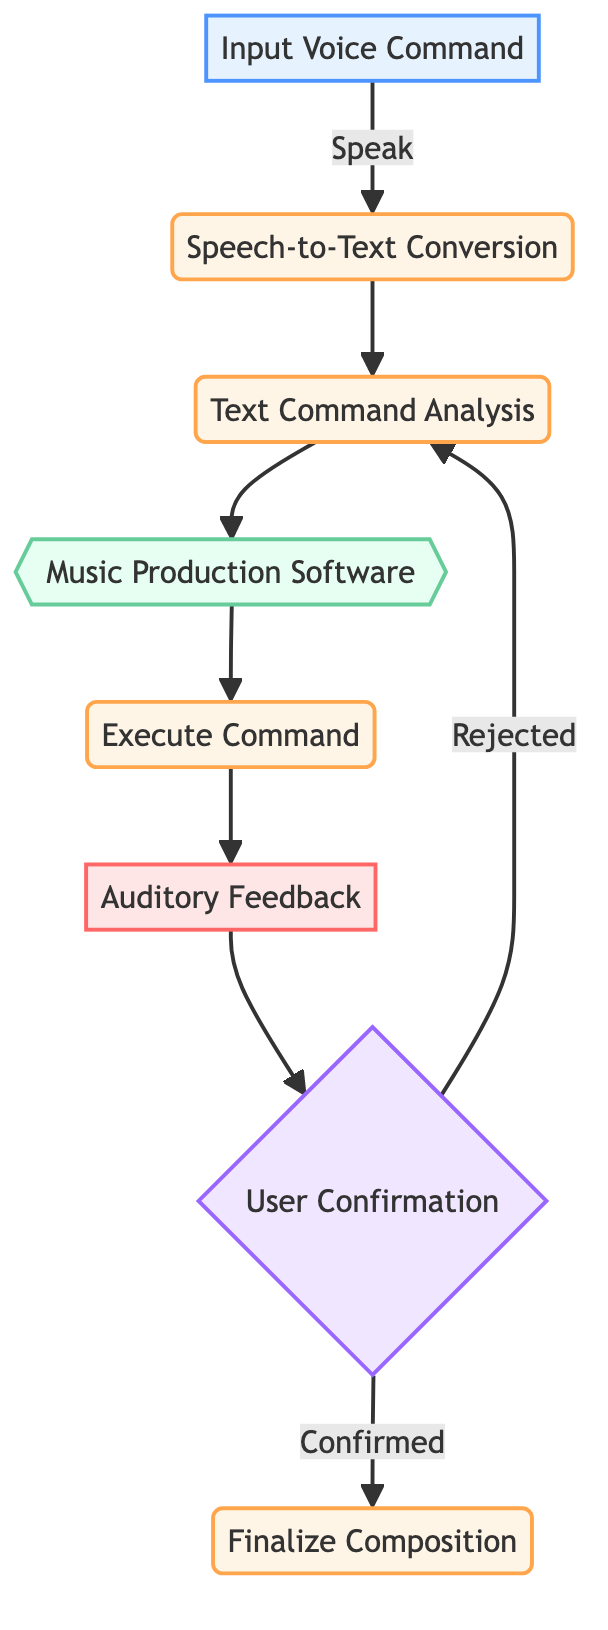What is the first step in the workflow? The first step involves the user speaking a command or musical idea into the microphone, indicated by the "Input Voice Command" node.
Answer: Input Voice Command How many processes are there in the diagram? There are four processes depicted in the diagram: "Speech-to-Text Conversion," "Text Command Analysis," "Execute Command," and "Finalize Composition."
Answer: 4 Which node follows the "Text Command Analysis"? The node that follows "Text Command Analysis" is "Music Production Software." This transition occurs directly after analyzing the text commands.
Answer: Music Production Software What happens if the user rejects the modifications? If the user rejects the modifications, the workflow returns to "Text Command Analysis" to refine the input commands as indicated by the decision path in the diagram.
Answer: Return to Text Command Analysis What type of node is "User Confirmation"? "User Confirmation" is a decision node, as it leads to two possible outcomes: confirmed or rejected, directing the flow accordingly.
Answer: Decision What is the output of the workflow after executing the command? After executing the command, the output is "Auditory Feedback," which allows the user to hear the result of their command through speakers or headphones.
Answer: Auditory Feedback If the command is confirmed, what is the next step? If the command is confirmed, the next step is "Finalize Composition," where the changes are saved.
Answer: Finalize Composition What type of software interacts with the workflow? The workflow interacts with "Music Production Software," which interfaces with various Digital Audio Workstations (DAWs).
Answer: Music Production Software 